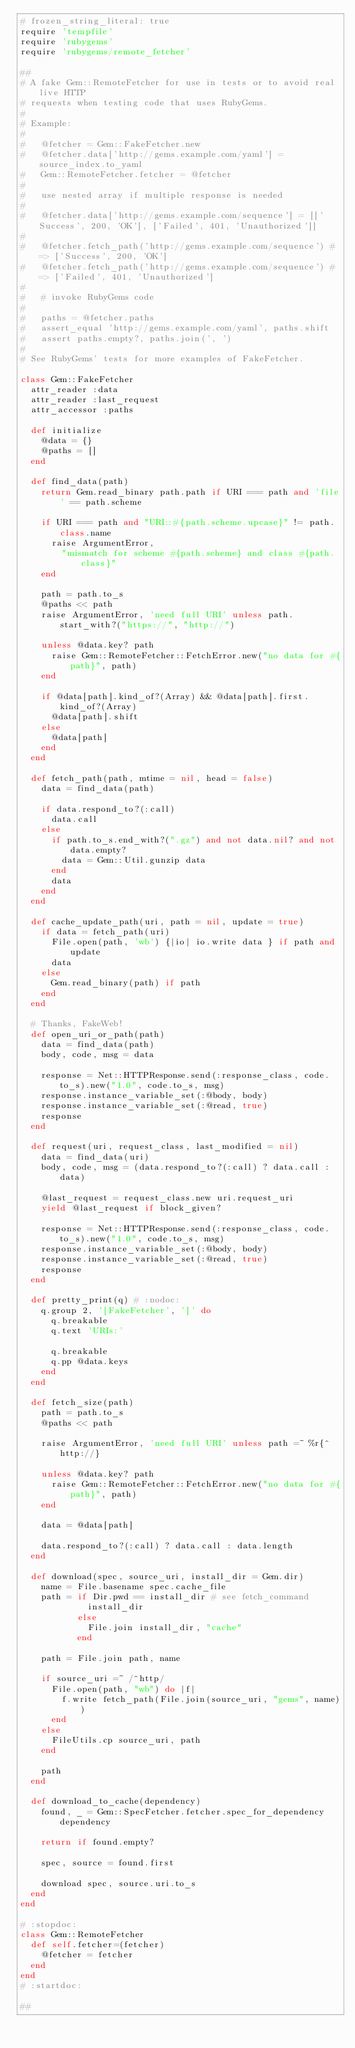<code> <loc_0><loc_0><loc_500><loc_500><_Ruby_># frozen_string_literal: true
require 'tempfile'
require 'rubygems'
require 'rubygems/remote_fetcher'

##
# A fake Gem::RemoteFetcher for use in tests or to avoid real live HTTP
# requests when testing code that uses RubyGems.
#
# Example:
#
#   @fetcher = Gem::FakeFetcher.new
#   @fetcher.data['http://gems.example.com/yaml'] = source_index.to_yaml
#   Gem::RemoteFetcher.fetcher = @fetcher
#
#   use nested array if multiple response is needed
#
#   @fetcher.data['http://gems.example.com/sequence'] = [['Success', 200, 'OK'], ['Failed', 401, 'Unauthorized']]
#
#   @fetcher.fetch_path('http://gems.example.com/sequence') # => ['Success', 200, 'OK']
#   @fetcher.fetch_path('http://gems.example.com/sequence') # => ['Failed', 401, 'Unauthorized']
#
#   # invoke RubyGems code
#
#   paths = @fetcher.paths
#   assert_equal 'http://gems.example.com/yaml', paths.shift
#   assert paths.empty?, paths.join(', ')
#
# See RubyGems' tests for more examples of FakeFetcher.

class Gem::FakeFetcher
  attr_reader :data
  attr_reader :last_request
  attr_accessor :paths

  def initialize
    @data = {}
    @paths = []
  end

  def find_data(path)
    return Gem.read_binary path.path if URI === path and 'file' == path.scheme

    if URI === path and "URI::#{path.scheme.upcase}" != path.class.name
      raise ArgumentError,
        "mismatch for scheme #{path.scheme} and class #{path.class}"
    end

    path = path.to_s
    @paths << path
    raise ArgumentError, 'need full URI' unless path.start_with?("https://", "http://")

    unless @data.key? path
      raise Gem::RemoteFetcher::FetchError.new("no data for #{path}", path)
    end

    if @data[path].kind_of?(Array) && @data[path].first.kind_of?(Array)
      @data[path].shift
    else
      @data[path]
    end
  end

  def fetch_path(path, mtime = nil, head = false)
    data = find_data(path)

    if data.respond_to?(:call)
      data.call
    else
      if path.to_s.end_with?(".gz") and not data.nil? and not data.empty?
        data = Gem::Util.gunzip data
      end
      data
    end
  end

  def cache_update_path(uri, path = nil, update = true)
    if data = fetch_path(uri)
      File.open(path, 'wb') {|io| io.write data } if path and update
      data
    else
      Gem.read_binary(path) if path
    end
  end

  # Thanks, FakeWeb!
  def open_uri_or_path(path)
    data = find_data(path)
    body, code, msg = data

    response = Net::HTTPResponse.send(:response_class, code.to_s).new("1.0", code.to_s, msg)
    response.instance_variable_set(:@body, body)
    response.instance_variable_set(:@read, true)
    response
  end

  def request(uri, request_class, last_modified = nil)
    data = find_data(uri)
    body, code, msg = (data.respond_to?(:call) ? data.call : data)

    @last_request = request_class.new uri.request_uri
    yield @last_request if block_given?

    response = Net::HTTPResponse.send(:response_class, code.to_s).new("1.0", code.to_s, msg)
    response.instance_variable_set(:@body, body)
    response.instance_variable_set(:@read, true)
    response
  end

  def pretty_print(q) # :nodoc:
    q.group 2, '[FakeFetcher', ']' do
      q.breakable
      q.text 'URIs:'

      q.breakable
      q.pp @data.keys
    end
  end

  def fetch_size(path)
    path = path.to_s
    @paths << path

    raise ArgumentError, 'need full URI' unless path =~ %r{^http://}

    unless @data.key? path
      raise Gem::RemoteFetcher::FetchError.new("no data for #{path}", path)
    end

    data = @data[path]

    data.respond_to?(:call) ? data.call : data.length
  end

  def download(spec, source_uri, install_dir = Gem.dir)
    name = File.basename spec.cache_file
    path = if Dir.pwd == install_dir # see fetch_command
             install_dir
           else
             File.join install_dir, "cache"
           end

    path = File.join path, name

    if source_uri =~ /^http/
      File.open(path, "wb") do |f|
        f.write fetch_path(File.join(source_uri, "gems", name))
      end
    else
      FileUtils.cp source_uri, path
    end

    path
  end

  def download_to_cache(dependency)
    found, _ = Gem::SpecFetcher.fetcher.spec_for_dependency dependency

    return if found.empty?

    spec, source = found.first

    download spec, source.uri.to_s
  end
end

# :stopdoc:
class Gem::RemoteFetcher
  def self.fetcher=(fetcher)
    @fetcher = fetcher
  end
end
# :startdoc:

##</code> 